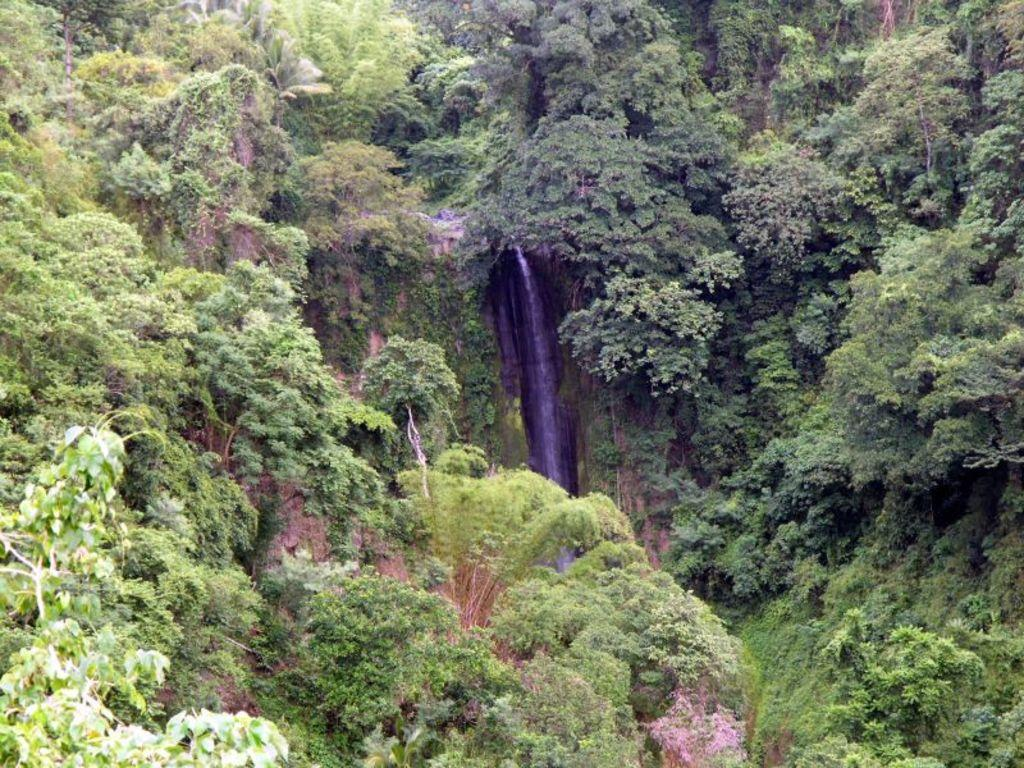What type of landscape is depicted in the image? The image contains mountains covered with grass. What can be found on the mountains in the image? The mountains have plants and trees. What is the water doing in the image? There is water flowing through rocks in the image. What type of grape is growing on the mountains in the image? There are no grapes present in the image; the mountains have plants and trees instead. How were the mountains transported to their current location in the image? The mountains were not transported to their current location; they are a natural part of the landscape. 